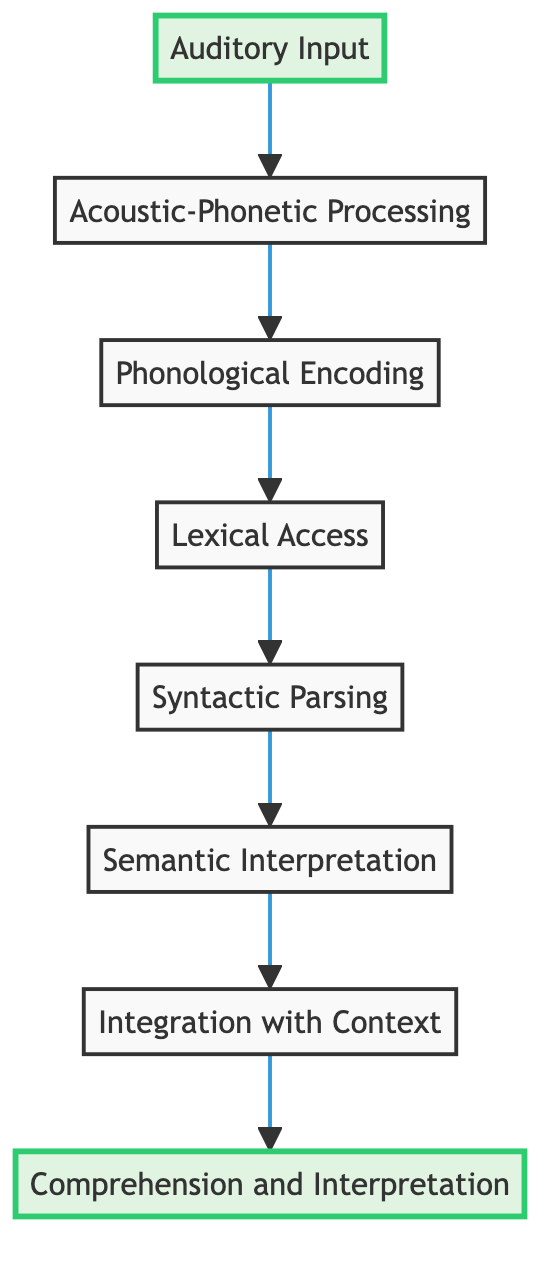What is the first step in the sentence comprehension process? The flow chart indicates that the first step in the process is "Auditory Input." This is shown as the starting point at the bottom of the diagram.
Answer: Auditory Input How many steps are there in the sentence comprehension flow? By counting the nodes in the flow chart, we see there are eight distinct steps from "Auditory Input" to "Comprehension and Interpretation."
Answer: Eight What follows "Lexical Access" in the process? According to the diagram, "Syntactic Parsing" comes directly after "Lexical Access." This indicates the progression from retrieving word meanings to constructing a syntactic structure.
Answer: Syntactic Parsing What is the last step in the comprehension process? The diagram shows that the final step of the process is "Comprehension and Interpretation," positioned at the top. This represents the culmination of the sentence comprehension process.
Answer: Comprehension and Interpretation Which step incorporates surrounding context and prior knowledge? The flow chart shows that "Integration with Context" is the step where surrounding context and prior knowledge are considered to refine understanding.
Answer: Integration with Context Which steps involve processing the phonetic representation of language? The steps "Acoustic-Phonetic Processing" and "Phonological Encoding" are the two that specifically deal with processing phonetic representation as indicated by their adjacency in the flow.
Answer: Acoustic-Phonetic Processing and Phonological Encoding How does "Semantic Interpretation" connect to the preceding steps? "Semantic Interpretation" follows "Syntactic Parsing," meaning it directly takes the syntactic structure constructed in the previous step and assigns meanings based on that structure.
Answer: It follows "Syntactic Parsing." What is the purpose of "Lexical Access" within the comprehension process? "Lexical Access" serves to retrieve word meanings and syntactic properties from the mental lexicon, which is essential for understanding sentence structure and meaning.
Answer: To retrieve word meanings and syntactic properties 